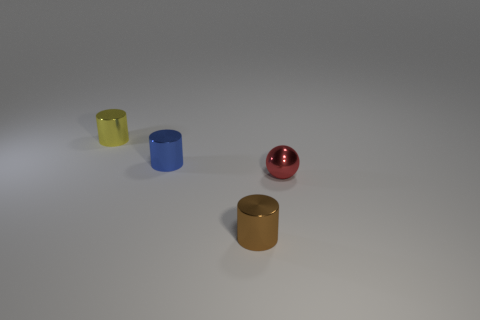Add 1 yellow metal cylinders. How many objects exist? 5 Subtract all yellow cylinders. How many cylinders are left? 2 Subtract all small blue cylinders. How many cylinders are left? 2 Subtract 1 brown cylinders. How many objects are left? 3 Subtract all balls. How many objects are left? 3 Subtract 1 spheres. How many spheres are left? 0 Subtract all red cylinders. Subtract all green cubes. How many cylinders are left? 3 Subtract all brown blocks. How many cyan spheres are left? 0 Subtract all big gray shiny things. Subtract all shiny spheres. How many objects are left? 3 Add 4 metallic things. How many metallic things are left? 8 